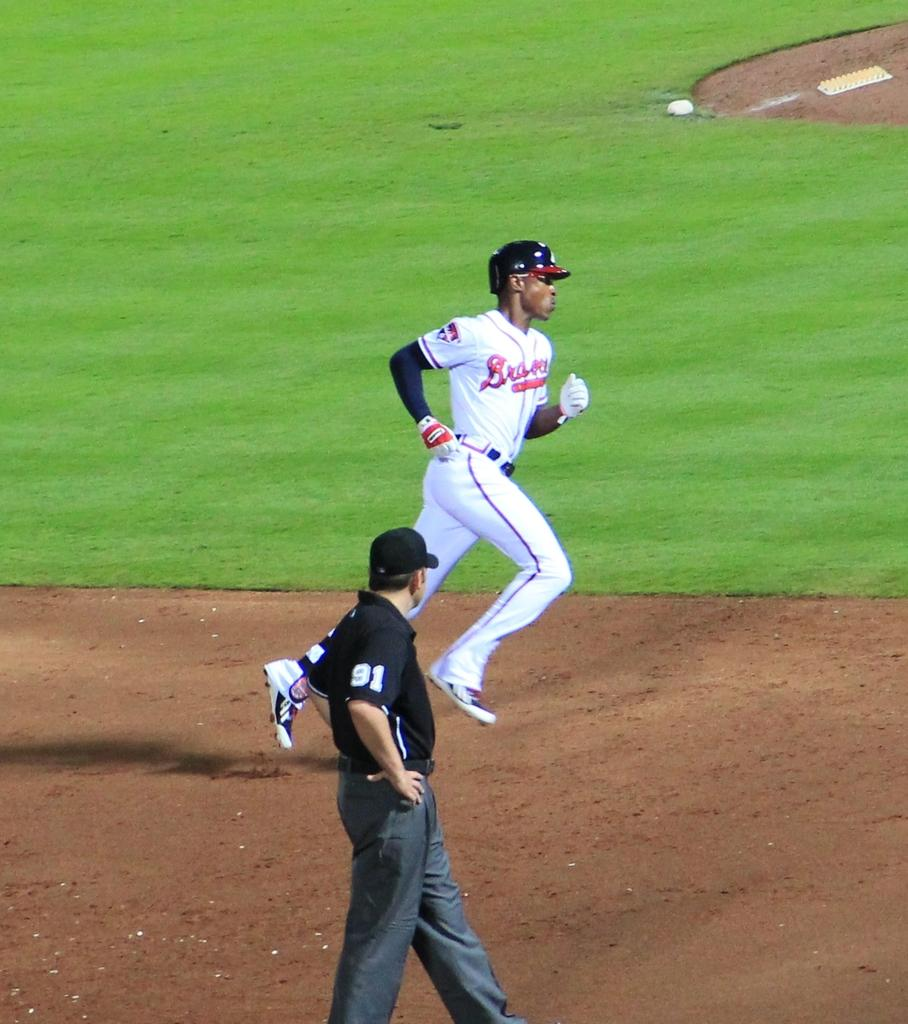<image>
Give a short and clear explanation of the subsequent image. A baseball umpire stands on a field at a game wearing a number 91 black t-shirt. 